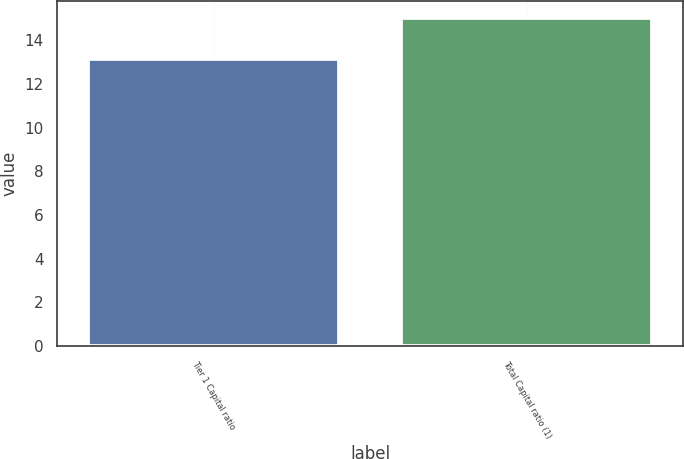<chart> <loc_0><loc_0><loc_500><loc_500><bar_chart><fcel>Tier 1 Capital ratio<fcel>Total Capital ratio (1)<nl><fcel>13.16<fcel>15.03<nl></chart> 